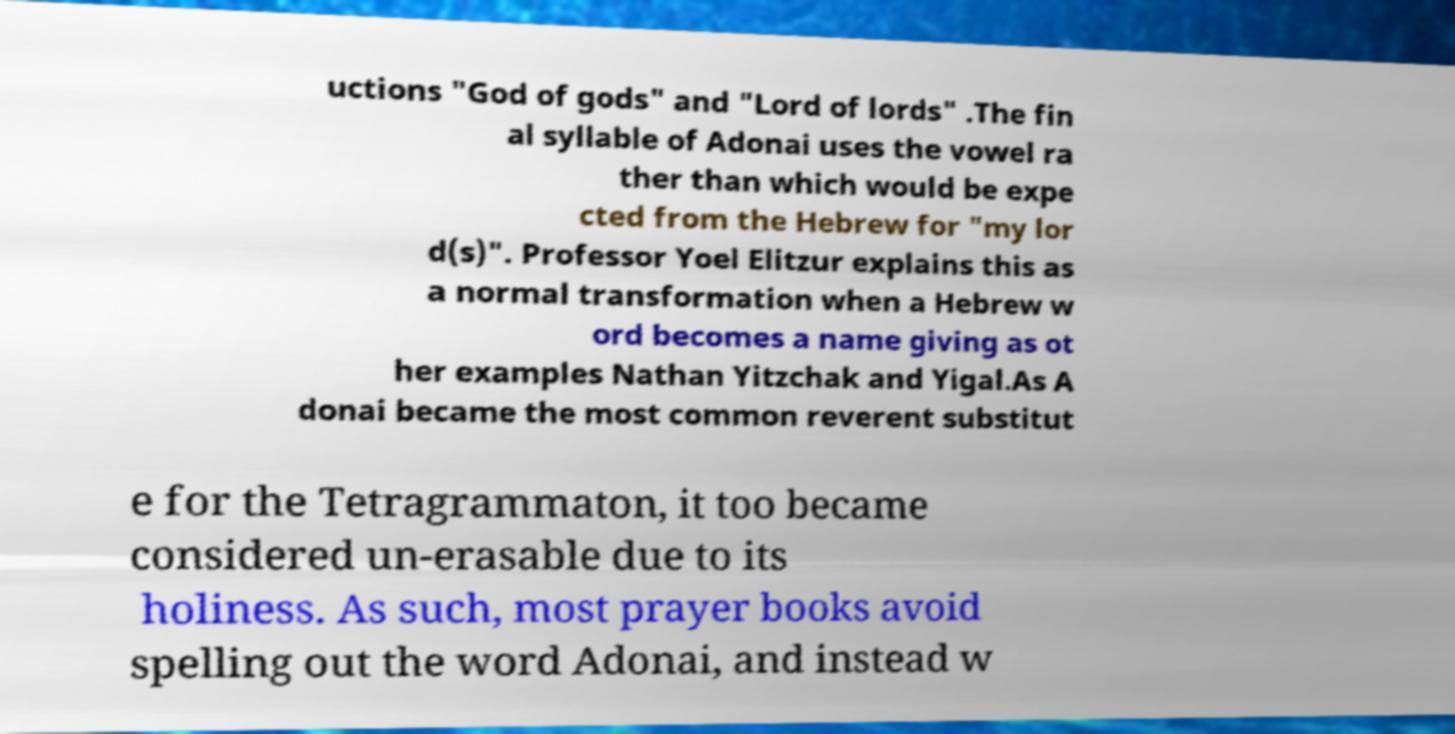Can you accurately transcribe the text from the provided image for me? uctions "God of gods" and "Lord of lords" .The fin al syllable of Adonai uses the vowel ra ther than which would be expe cted from the Hebrew for "my lor d(s)". Professor Yoel Elitzur explains this as a normal transformation when a Hebrew w ord becomes a name giving as ot her examples Nathan Yitzchak and Yigal.As A donai became the most common reverent substitut e for the Tetragrammaton, it too became considered un-erasable due to its holiness. As such, most prayer books avoid spelling out the word Adonai, and instead w 